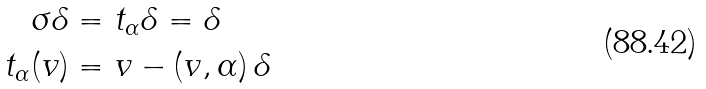<formula> <loc_0><loc_0><loc_500><loc_500>\sigma \delta & = t _ { \alpha } \delta = \delta \\ t _ { \alpha } ( v ) & = v - ( v , \alpha ) \, \delta</formula> 